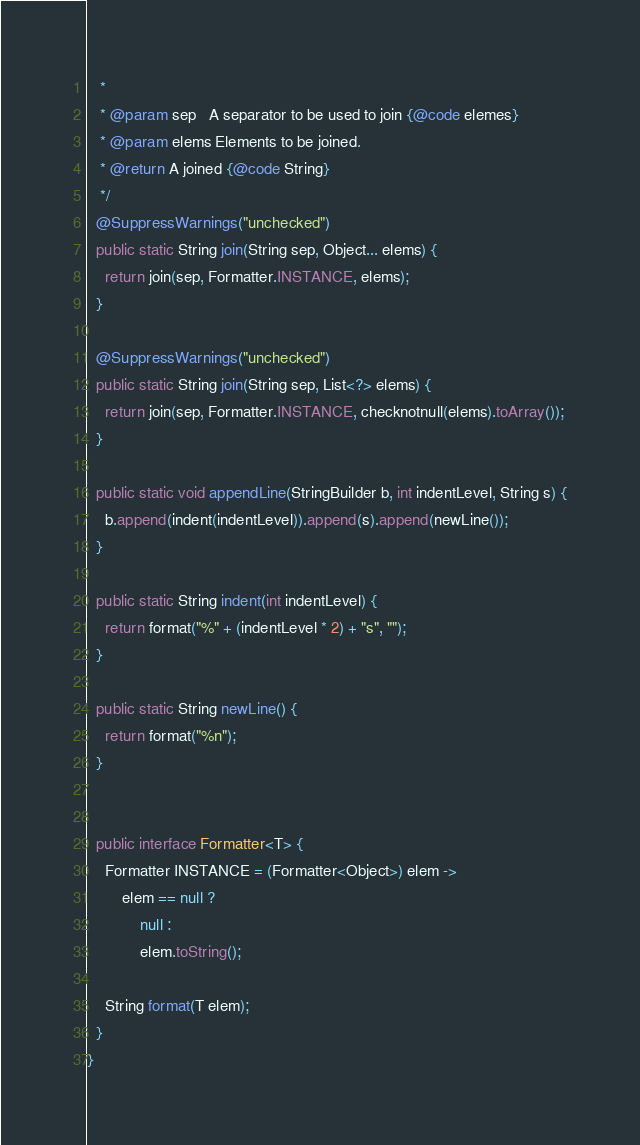<code> <loc_0><loc_0><loc_500><loc_500><_Java_>   *
   * @param sep   A separator to be used to join {@code elemes}
   * @param elems Elements to be joined.
   * @return A joined {@code String}
   */
  @SuppressWarnings("unchecked")
  public static String join(String sep, Object... elems) {
    return join(sep, Formatter.INSTANCE, elems);
  }

  @SuppressWarnings("unchecked")
  public static String join(String sep, List<?> elems) {
    return join(sep, Formatter.INSTANCE, checknotnull(elems).toArray());
  }

  public static void appendLine(StringBuilder b, int indentLevel, String s) {
    b.append(indent(indentLevel)).append(s).append(newLine());
  }

  public static String indent(int indentLevel) {
    return format("%" + (indentLevel * 2) + "s", "");
  }

  public static String newLine() {
    return format("%n");
  }


  public interface Formatter<T> {
    Formatter INSTANCE = (Formatter<Object>) elem ->
        elem == null ?
            null :
            elem.toString();

    String format(T elem);
  }
}
</code> 